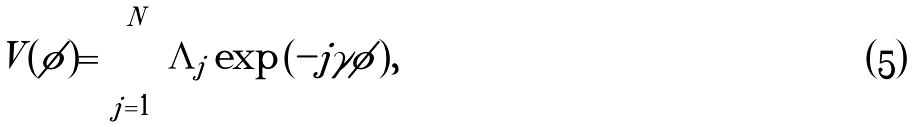<formula> <loc_0><loc_0><loc_500><loc_500>V ( \phi ) = \sum _ { j = 1 } ^ { N } { \Lambda _ { j } \exp { ( - j \gamma \phi ) } } ,</formula> 